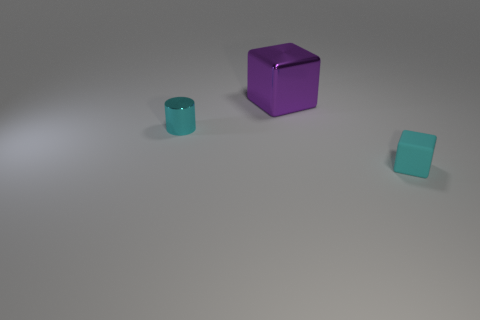Is there any other thing that is the same size as the purple metallic thing?
Give a very brief answer. No. There is a cyan object that is the same shape as the purple metal thing; what size is it?
Provide a short and direct response. Small. Are there any other things that have the same material as the cyan cube?
Make the answer very short. No. There is a cyan thing that is behind the small cyan rubber object; does it have the same size as the thing behind the small metallic cylinder?
Give a very brief answer. No. What number of small things are either cyan shiny things or purple metal things?
Keep it short and to the point. 1. How many objects are in front of the tiny cylinder and left of the cyan rubber block?
Your answer should be very brief. 0. Are the cyan cylinder and the block that is behind the tiny matte object made of the same material?
Ensure brevity in your answer.  Yes. How many yellow objects are either small metallic objects or big shiny cubes?
Offer a terse response. 0. Are there any objects of the same size as the cyan cube?
Offer a very short reply. Yes. The cyan thing behind the cyan thing on the right side of the metal thing right of the small cyan cylinder is made of what material?
Ensure brevity in your answer.  Metal. 